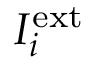Convert formula to latex. <formula><loc_0><loc_0><loc_500><loc_500>I _ { i } ^ { e x t }</formula> 